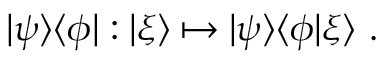<formula> <loc_0><loc_0><loc_500><loc_500>| \psi \rangle \langle \phi | \colon | \xi \rangle \mapsto | \psi \rangle \langle \phi | \xi \rangle .</formula> 